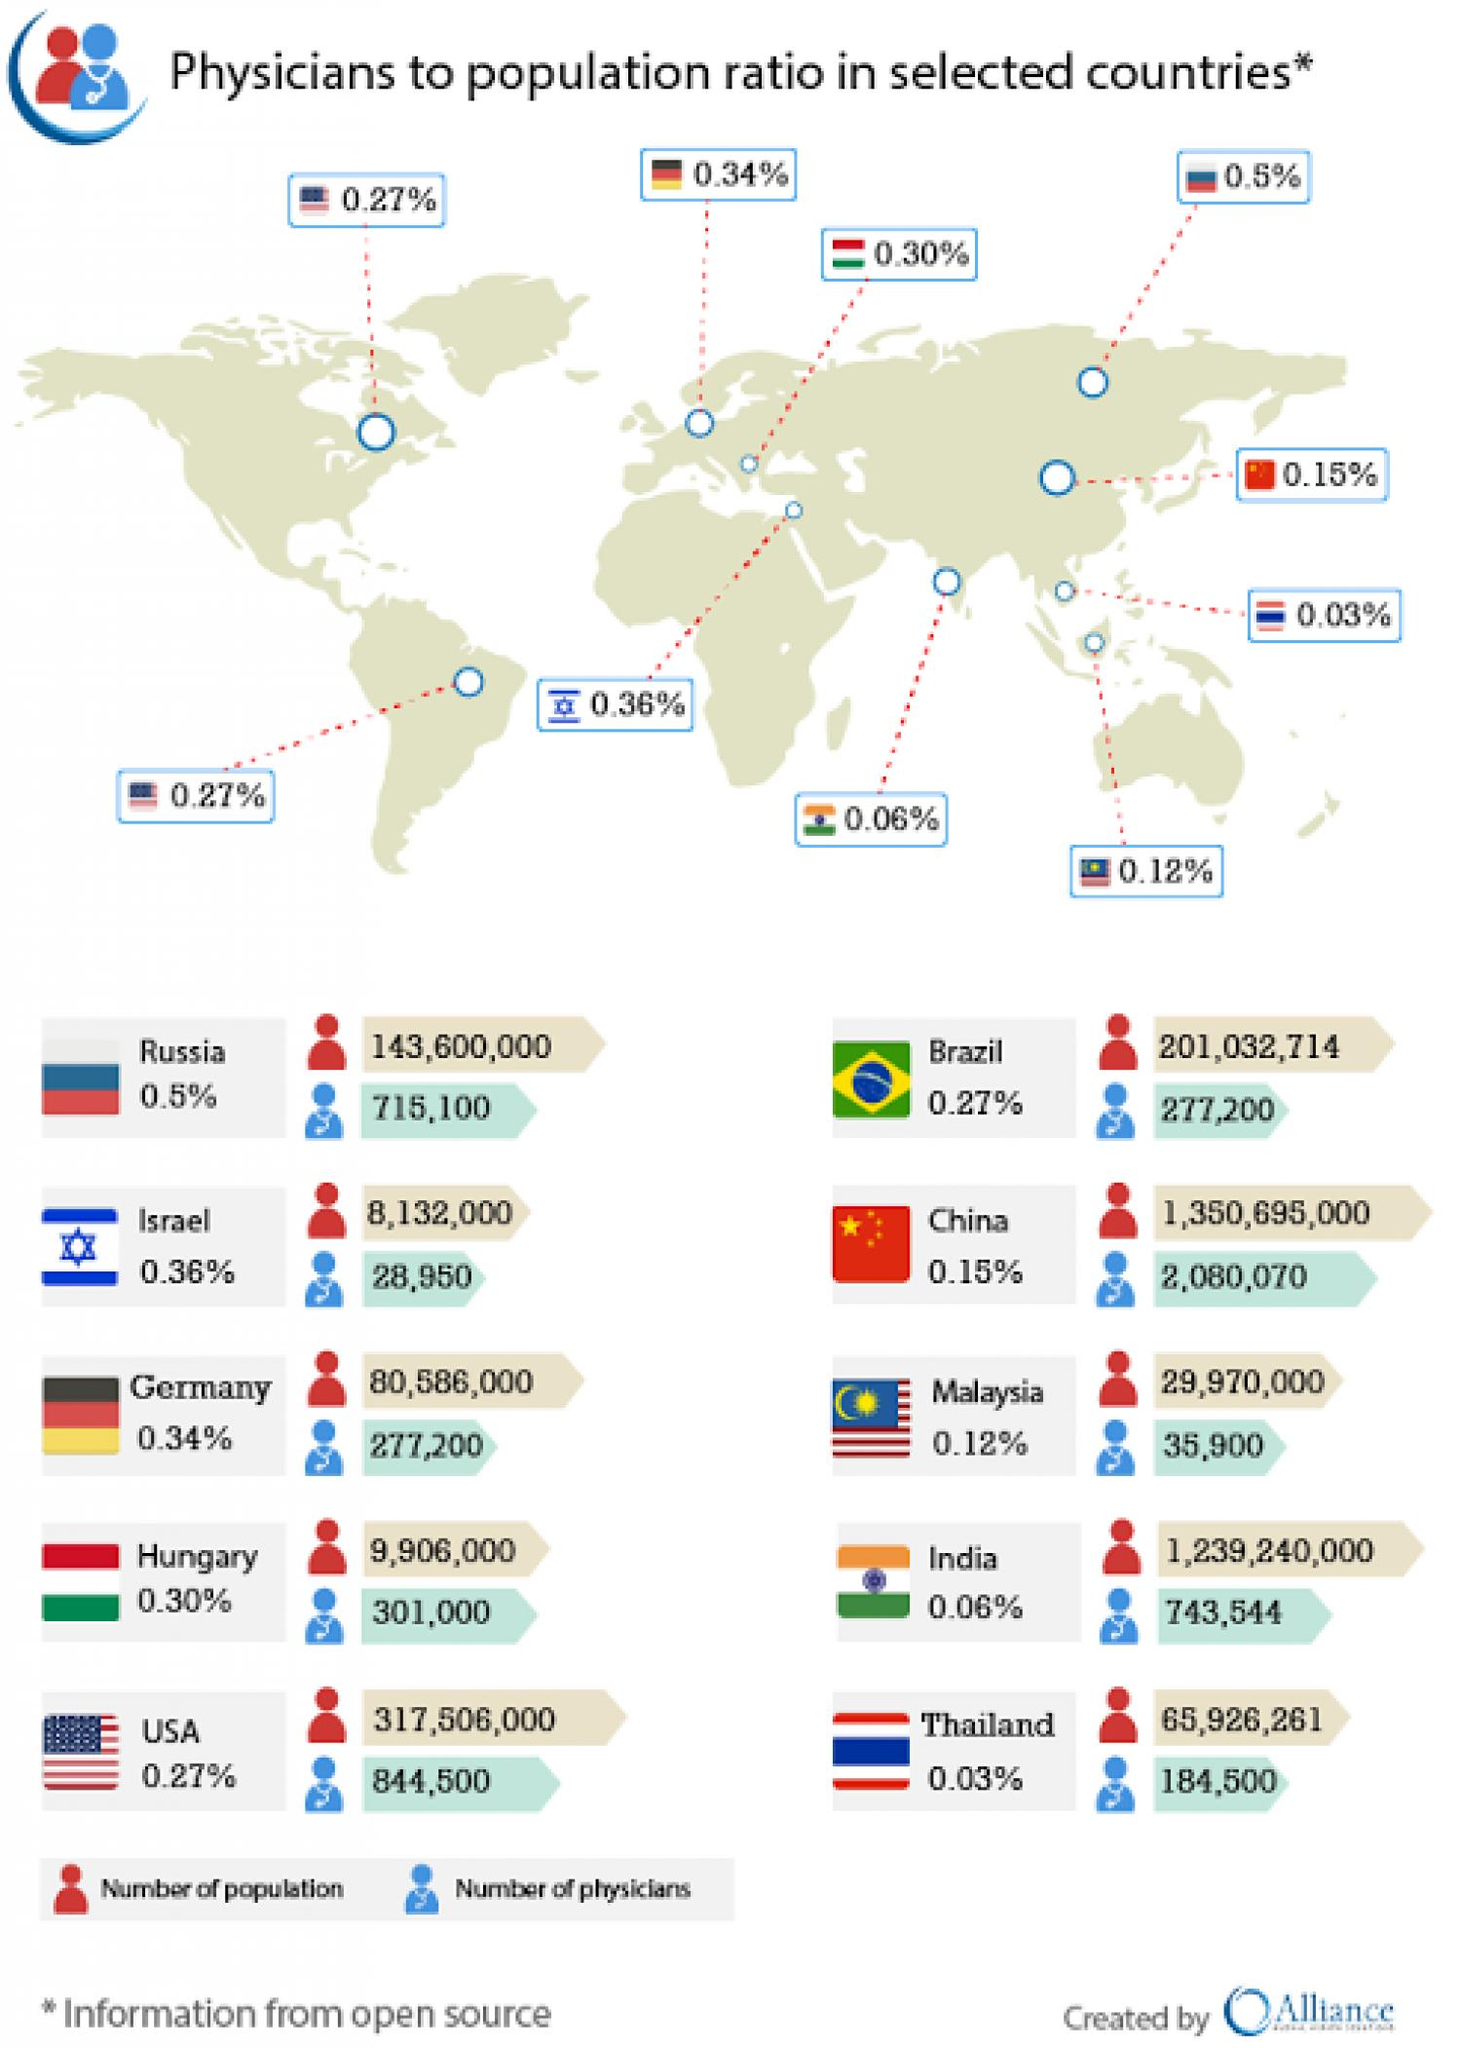Highlight a few significant elements in this photo. The combined physician to population ratio of Brazil and China is 0.42%. The physician-to-population ratio of Russia and Israel, taken together, is 0.86%. 